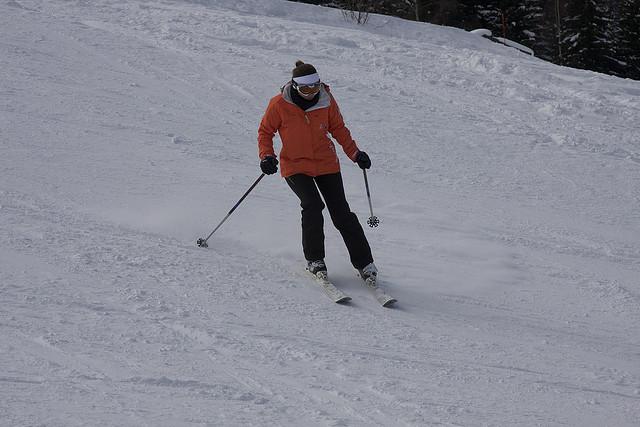How many people are shown?
Quick response, please. 1. Is the skier in a competition?
Short answer required. No. Should she wear sunblock?
Write a very short answer. No. Is the skier any good?
Short answer required. Yes. Is the lady in the red coat wearing sunglasses?
Keep it brief. No. What season was this photo taken?
Short answer required. Winter. What is the gender of the skier?
Be succinct. Female. What color is the snow?
Answer briefly. White. 